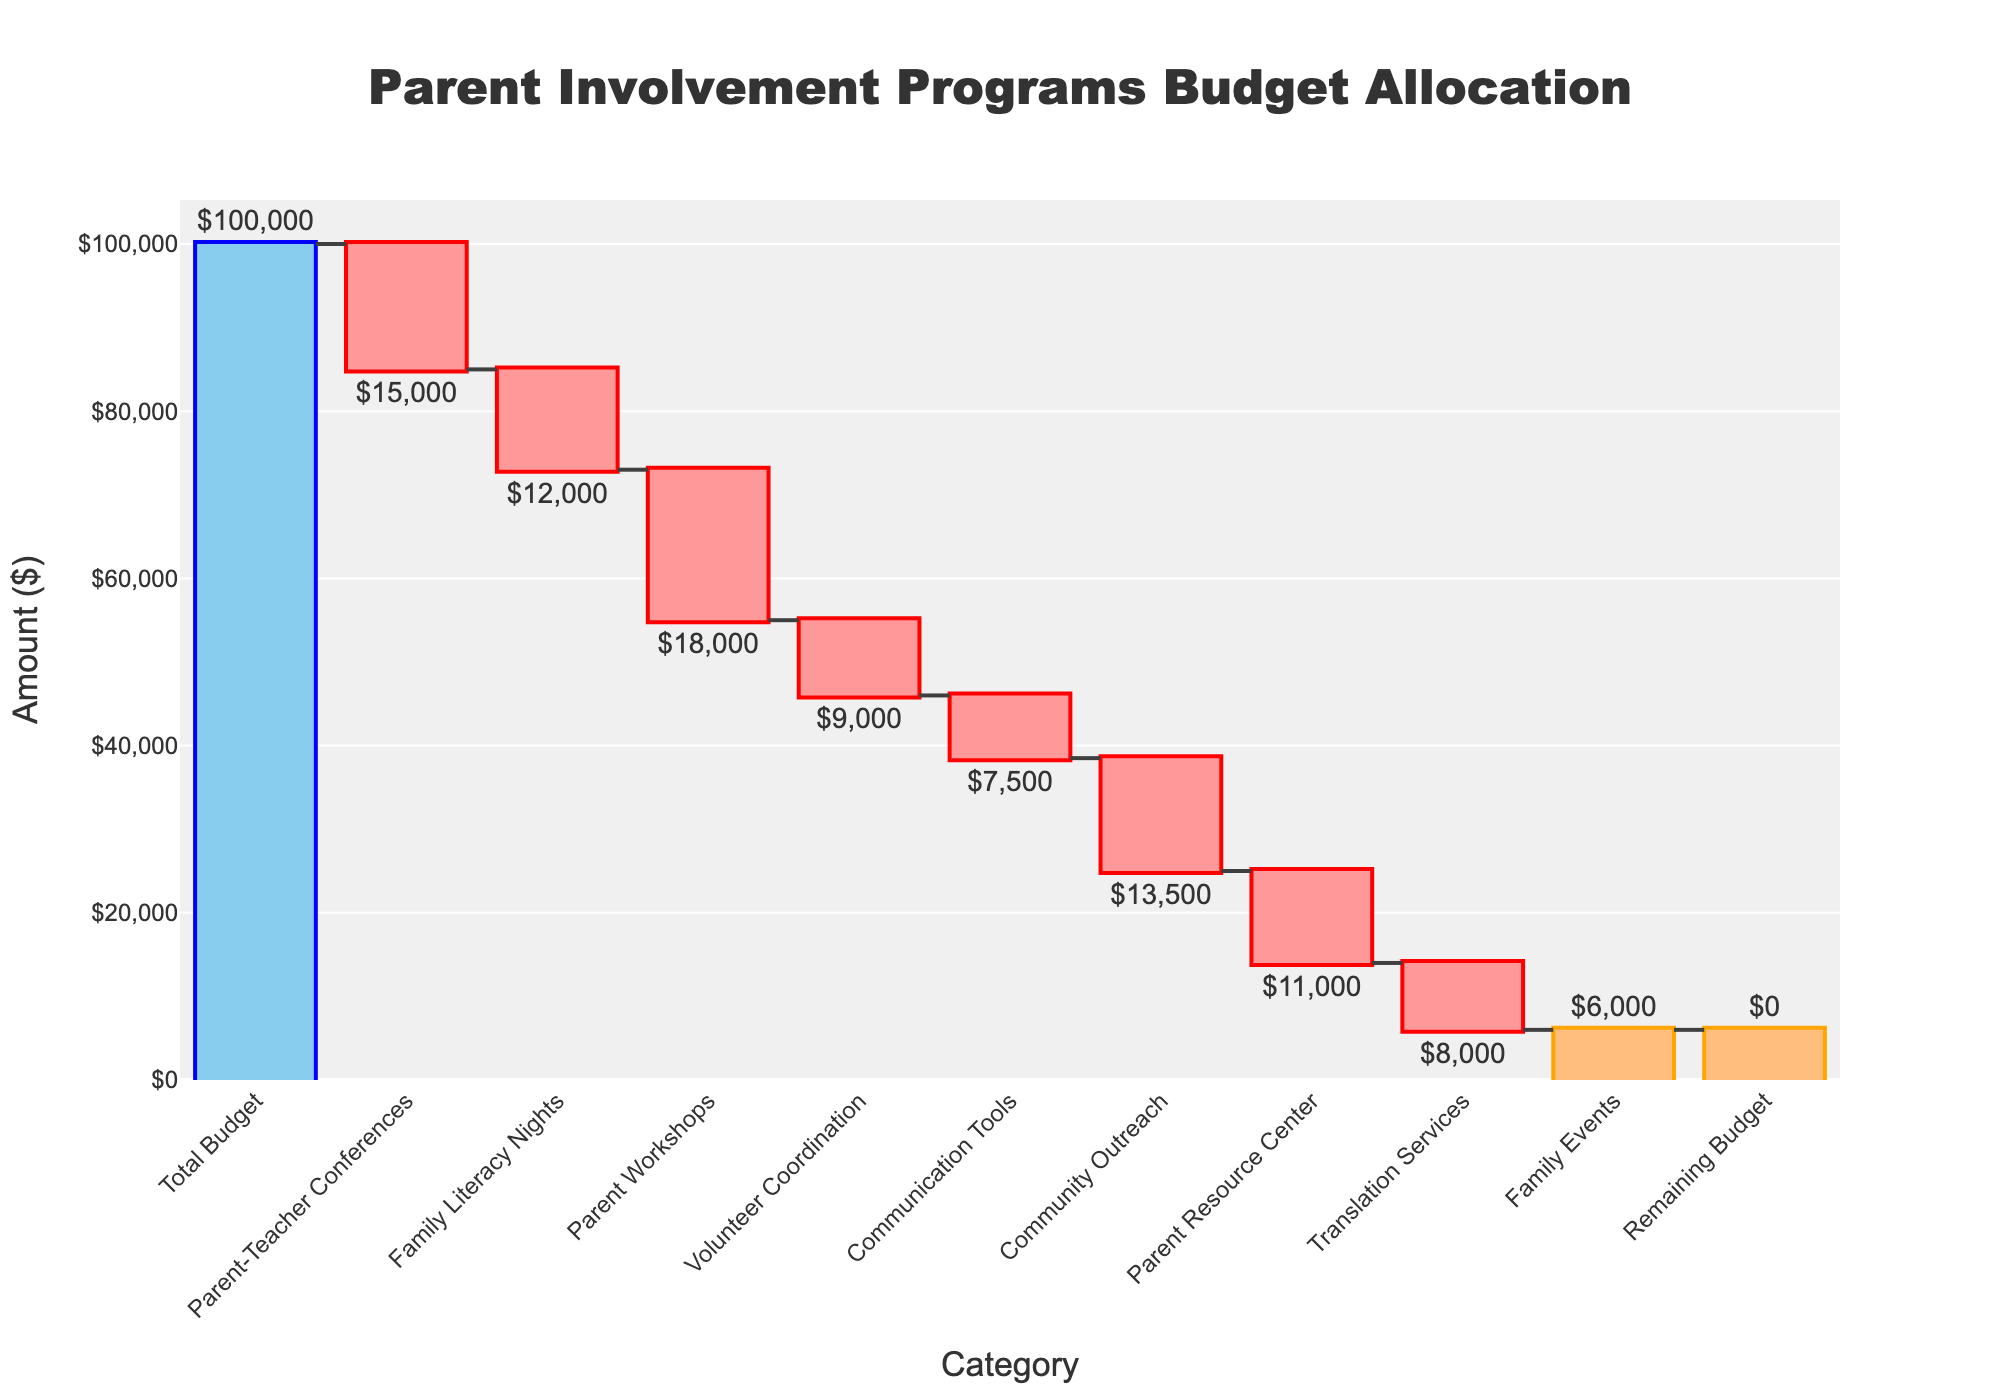What is the title of the chart? The title of the chart appears at the top and is centered. It states "Parent Involvement Programs Budget Allocation."
Answer: Parent Involvement Programs Budget Allocation How much was allocated to Parent Workshops? Locate the bar labeled "Parent Workshops" and read the value associated with it. It shows a decrease of $18,000.
Answer: $18,000 Which initiative received the least funding? Compare the values of all the negative bars and find that "Family Events" has the smallest absolute value of $6,000.
Answer: Family Events How much of the budget remains unallocated? The "Remaining Budget" bar at the end shows a value of $0, indicating no remaining funds.
Answer: $0 What was the total amount allocated across all the initiatives? Sum all the negative values: -15,000 (Parent-Teacher Conferences) + -12,000 (Family Literacy Nights) + -18,000 (Parent Workshops) + -9,000 (Volunteer Coordination) + -7,500 (Communication Tools) + -13,500 (Community Outreach) + -11,000 (Parent Resource Center) + -8,000 (Translation Services) + -6,000 (Family Events) = -100,000.
Answer: $100,000 Which category had higher funding, Parent Resource Center or Translation Services? Compare the absolute values of funding for both categories: $11,000 for Parent Resource Center vs $8,000 for Translation Services.
Answer: Parent Resource Center What is the total budget shown in the chart? The "Total Budget" bar at the very beginning shows the initial budget amount, which is $100,000.
Answer: $100,000 By how much does the Parent-Teacher Conferences funding exceed Communication Tools funding? Calculate the absolute difference: $15,000 (Parent-Teacher Conferences) - $7,500 (Communication Tools) = $7,500.
Answer: $7,500 If Volunteer Coordination funding was increased by $1,000, what would be the new amount? Given the original allocation of $9,000, add $1,000 to get $10,000.
Answer: $10,000 What are the colors used for the decreasing bars in the chart? The decreasing bars are shown in shades of reddish colors.
Answer: Red 